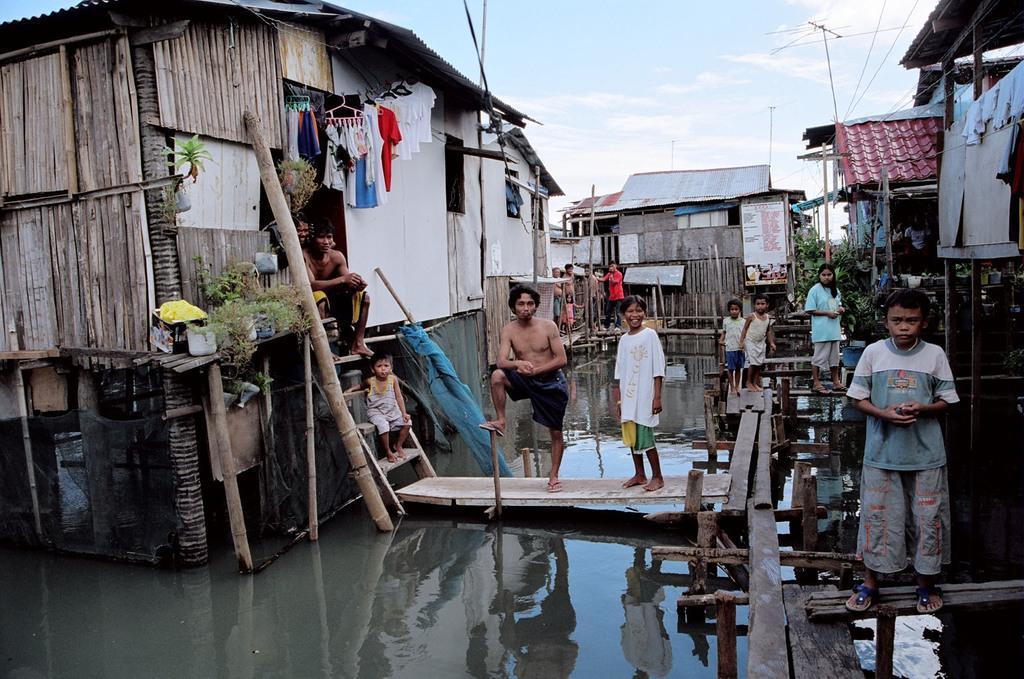Describe this image in one or two sentences. In this image I can see few houses and some people standing on the wooden bridge, under that there is some water. 